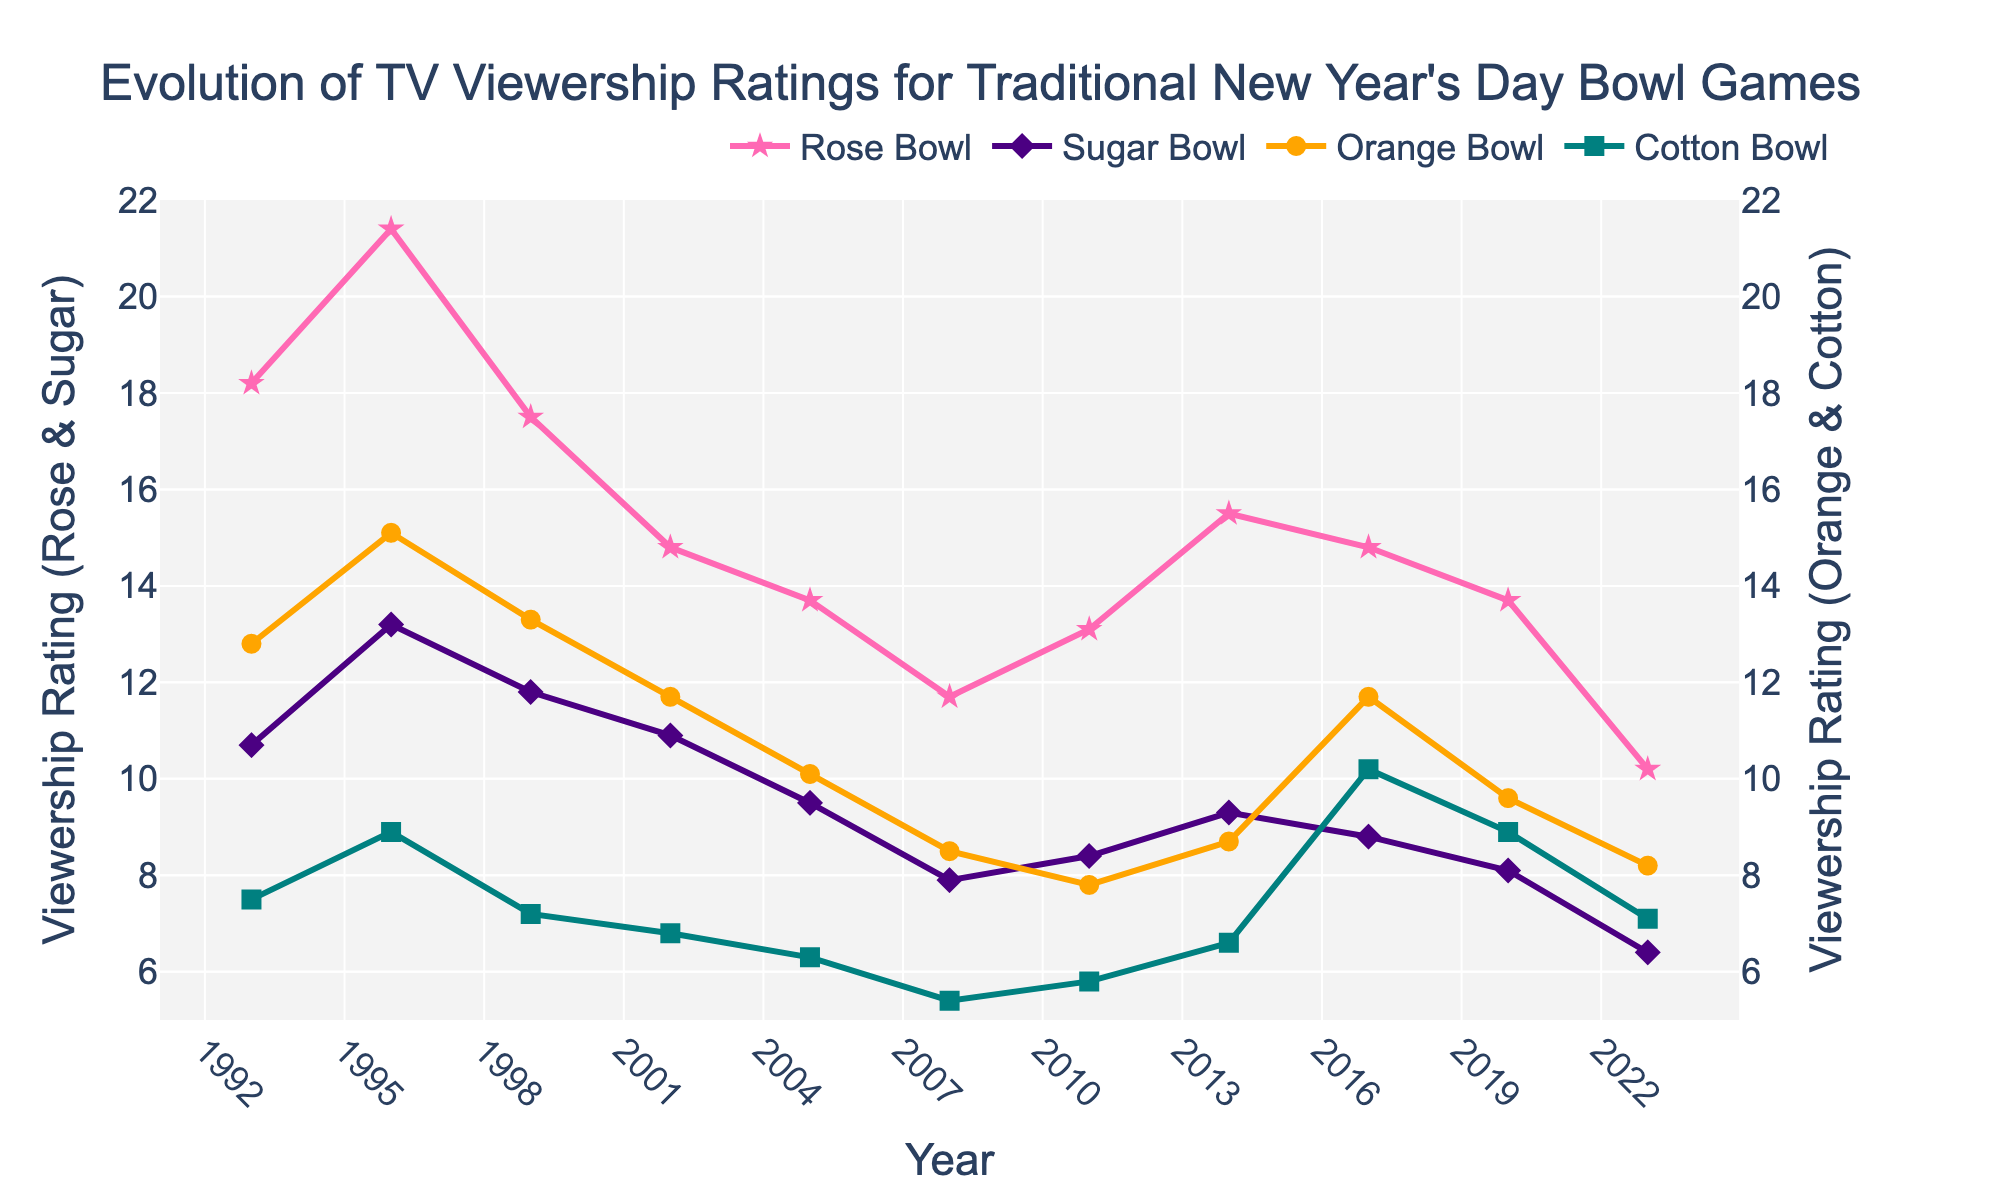What year had the highest viewership rating for the Rose Bowl? Looking at the data points for the Rose Bowl, the highest viewership rating is 21.4, which occurred in the year 1996.
Answer: 1996 Which bowl game had the lowest viewership rating in 2023? Observing the data for the year 2023, the lowest viewership rating among the four bowl games is for the Sugar Bowl, which has a rating of 6.4.
Answer: Sugar Bowl How did the viewership rating for the Cotton Bowl change from 1993 to 2023? The viewership rating for the Cotton Bowl in 1993 was 7.5, and by 2023, it was 7.1. So, the change can be calculated as 7.1 - 7.5 = -0.4, indicating a decrease.
Answer: Decreased by 0.4 What is the average viewership rating of the Sugar Bowl over the 30-year span? To calculate the average, sum all the viewership ratings of the Sugar Bowl (10.7 + 13.2 + 11.8 + 10.9 + 9.5 + 7.9 + 8.4 + 9.3 + 8.8 + 8.1 + 6.4 = 105) and then divide by the number of years (11). The average is 105 / 11 ≈ 9.55.
Answer: 9.55 Compare the trends of the Rose Bowl and Orange Bowl viewership ratings from 1993 to 2023. The trend for both bowls shows a decrease over time, but the Rose Bowl has a sharper drop from 18.2 to 10.2 compared to the Orange Bowl, which starts at 12.8 and ends at 8.2. Thus, the Rose Bowl’s ratings generally decrease more significantly than the Orange Bowl’s.
Answer: Rose Bowl's ratings decrease more significantly What was the biggest year-to-year drop in viewership for the Rose Bowl? Calculate the year-to-year differences: 
1993 to 1996: 21.4 - 18.2 = 3.2 increase,
1996 to 1999: 21.4 - 17.5 = 3.9 decrease,
1999 to 2002: 17.5 - 14.8 = 2.7 decrease,
2002 to 2005: 14.8 - 13.7 = 1.1 decrease,
2005 to 2008: 13.7 - 11.7 = 2 decrease,
2008 to 2011: 11.7 - 13.1 = 1.4 increase,
2011 to 2014: 13.1 - 15.5 = 2.4 increase,
2014 to 2017: 15.5 - 14.8 = 0.7 decrease,
2017 to 2020: 14.8 - 13.7 = 1.1 decrease,
2020 to 2023: 13.7 - 10.2 = 3.5 decrease.
The largest drop is from 2020 to 2023 with 3.5.
Answer: 2020 to 2023 In which year did the Orange Bowl and Cotton Bowl have the same viewership rating? By inspecting the data, we find that in 2002, both the Orange Bowl and Cotton Bowl had a viewership rating of 6.8.
Answer: 2002 What was the cumulative viewership rating for all four bowl games in 1996? Sum the viewership ratings for 1996: 21.4 (Rose Bowl) + 13.2 (Sugar Bowl) + 15.1 (Orange Bowl) + 8.9 (Cotton Bowl) = 58.6.
Answer: 58.6 Which bowl game showed the most improvement in viewership rating from 2008 to 2011? Check the viewership differences:
Rose Bowl: 13.1 - 11.7 = 1.4 increase,
Sugar Bowl: 8.4 - 7.9 = 0.5 increase,
Orange Bowl: 7.8 - 8.5 = -0.7 decrease,
Cotton Bowl: 5.8 - 5.4 = 0.4 increase.
The Rose Bowl showed the most improvement with an increase of 1.4.
Answer: Rose Bowl 